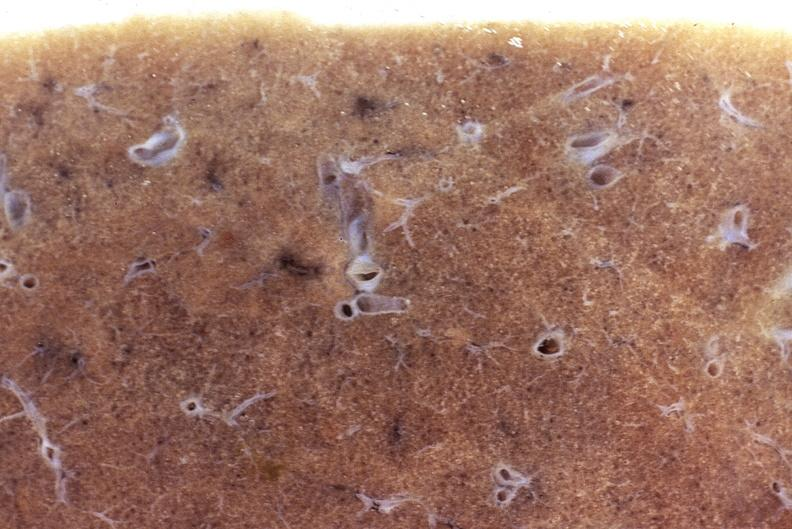where is this?
Answer the question using a single word or phrase. Lung 